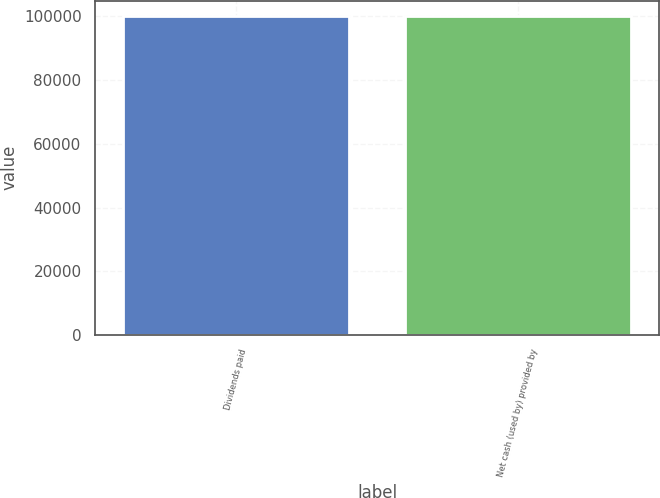<chart> <loc_0><loc_0><loc_500><loc_500><bar_chart><fcel>Dividends paid<fcel>Net cash (used by) provided by<nl><fcel>100000<fcel>100000<nl></chart> 